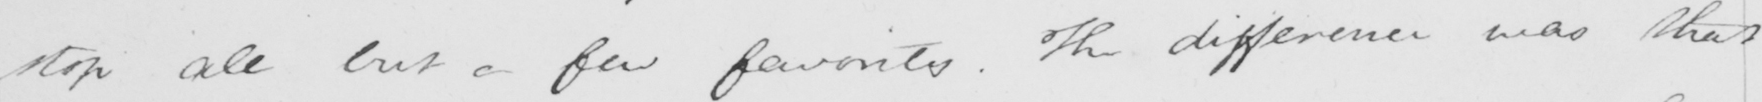Can you tell me what this handwritten text says? stop all but a few favorites . The difference was that 